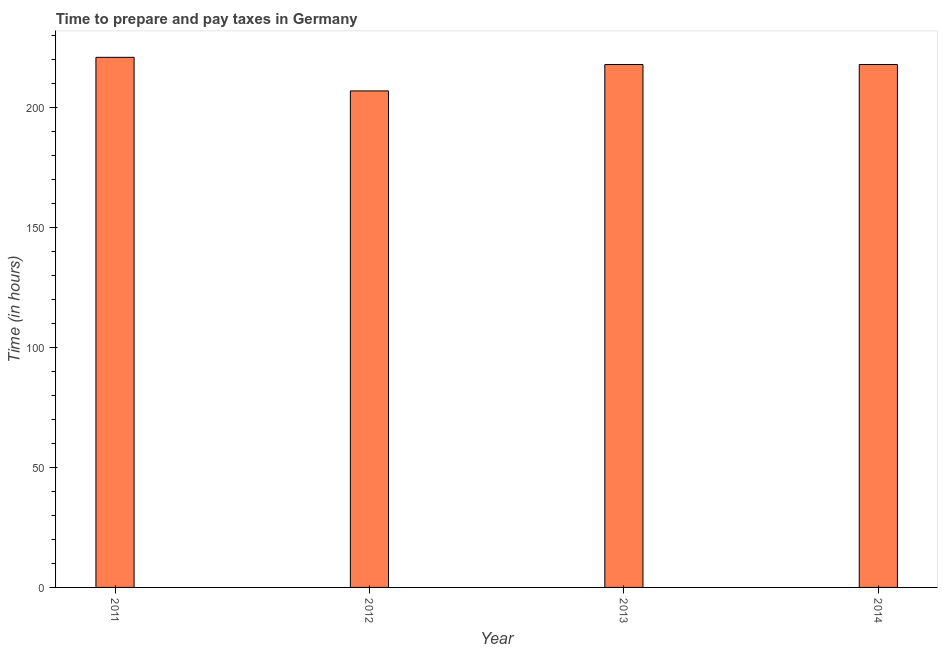Does the graph contain any zero values?
Your response must be concise. No. Does the graph contain grids?
Give a very brief answer. No. What is the title of the graph?
Provide a short and direct response. Time to prepare and pay taxes in Germany. What is the label or title of the Y-axis?
Your answer should be very brief. Time (in hours). What is the time to prepare and pay taxes in 2011?
Provide a short and direct response. 221. Across all years, what is the maximum time to prepare and pay taxes?
Provide a succinct answer. 221. Across all years, what is the minimum time to prepare and pay taxes?
Your response must be concise. 207. In which year was the time to prepare and pay taxes maximum?
Provide a succinct answer. 2011. What is the sum of the time to prepare and pay taxes?
Your answer should be very brief. 864. What is the average time to prepare and pay taxes per year?
Give a very brief answer. 216. What is the median time to prepare and pay taxes?
Your response must be concise. 218. What is the ratio of the time to prepare and pay taxes in 2011 to that in 2012?
Provide a succinct answer. 1.07. Is the difference between the time to prepare and pay taxes in 2012 and 2014 greater than the difference between any two years?
Offer a very short reply. No. Is the sum of the time to prepare and pay taxes in 2012 and 2013 greater than the maximum time to prepare and pay taxes across all years?
Provide a succinct answer. Yes. In how many years, is the time to prepare and pay taxes greater than the average time to prepare and pay taxes taken over all years?
Ensure brevity in your answer.  3. Are all the bars in the graph horizontal?
Your answer should be very brief. No. What is the difference between two consecutive major ticks on the Y-axis?
Provide a succinct answer. 50. Are the values on the major ticks of Y-axis written in scientific E-notation?
Ensure brevity in your answer.  No. What is the Time (in hours) in 2011?
Provide a succinct answer. 221. What is the Time (in hours) in 2012?
Your answer should be compact. 207. What is the Time (in hours) of 2013?
Give a very brief answer. 218. What is the Time (in hours) of 2014?
Your response must be concise. 218. What is the difference between the Time (in hours) in 2011 and 2012?
Keep it short and to the point. 14. What is the difference between the Time (in hours) in 2011 and 2014?
Keep it short and to the point. 3. What is the difference between the Time (in hours) in 2012 and 2013?
Give a very brief answer. -11. What is the difference between the Time (in hours) in 2012 and 2014?
Your response must be concise. -11. What is the difference between the Time (in hours) in 2013 and 2014?
Offer a terse response. 0. What is the ratio of the Time (in hours) in 2011 to that in 2012?
Ensure brevity in your answer.  1.07. What is the ratio of the Time (in hours) in 2011 to that in 2013?
Your answer should be compact. 1.01. What is the ratio of the Time (in hours) in 2011 to that in 2014?
Give a very brief answer. 1.01. What is the ratio of the Time (in hours) in 2012 to that in 2013?
Give a very brief answer. 0.95. 